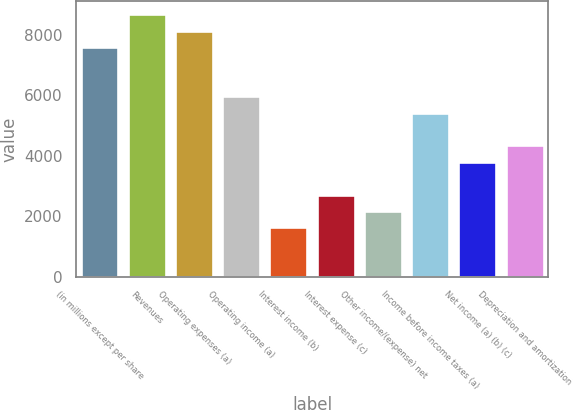Convert chart. <chart><loc_0><loc_0><loc_500><loc_500><bar_chart><fcel>(in millions except per share<fcel>Revenues<fcel>Operating expenses (a)<fcel>Operating income (a)<fcel>Interest income (b)<fcel>Interest expense (c)<fcel>Other income/(expense) net<fcel>Income before income taxes (a)<fcel>Net income (a) (b) (c)<fcel>Depreciation and amortization<nl><fcel>7591.87<fcel>8676.35<fcel>8134.11<fcel>5965.15<fcel>1627.23<fcel>2711.71<fcel>2169.47<fcel>5422.91<fcel>3796.19<fcel>4338.43<nl></chart> 